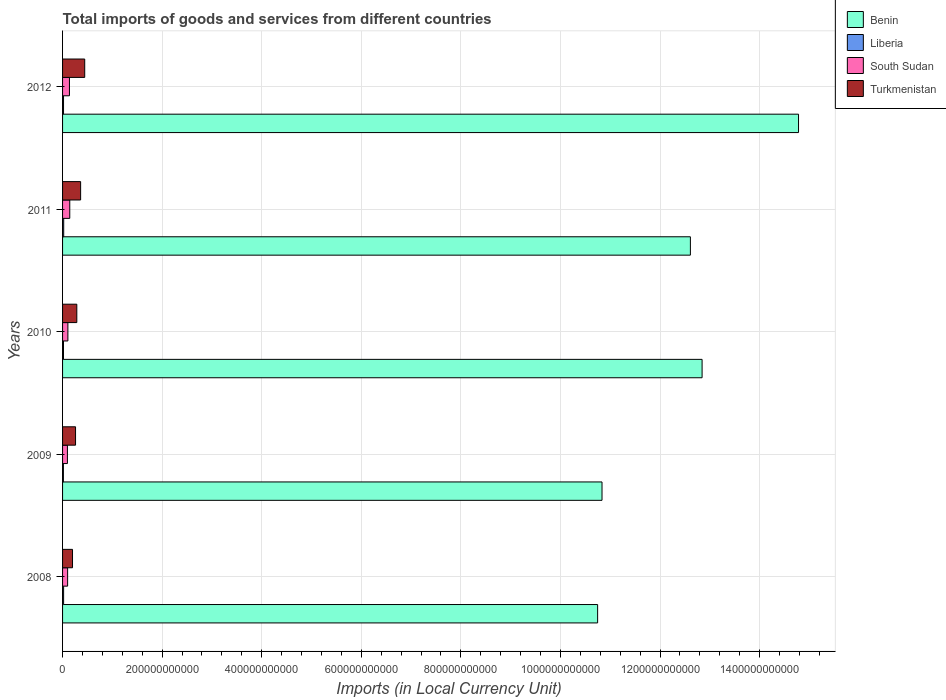How many different coloured bars are there?
Give a very brief answer. 4. Are the number of bars per tick equal to the number of legend labels?
Provide a short and direct response. Yes. Are the number of bars on each tick of the Y-axis equal?
Provide a succinct answer. Yes. How many bars are there on the 4th tick from the bottom?
Give a very brief answer. 4. What is the Amount of goods and services imports in Liberia in 2011?
Your answer should be very brief. 2.27e+09. Across all years, what is the maximum Amount of goods and services imports in South Sudan?
Ensure brevity in your answer.  1.45e+1. Across all years, what is the minimum Amount of goods and services imports in Turkmenistan?
Give a very brief answer. 2.00e+1. In which year was the Amount of goods and services imports in Benin maximum?
Your answer should be compact. 2012. What is the total Amount of goods and services imports in Turkmenistan in the graph?
Ensure brevity in your answer.  1.55e+11. What is the difference between the Amount of goods and services imports in Benin in 2009 and that in 2012?
Offer a terse response. -3.95e+11. What is the difference between the Amount of goods and services imports in Benin in 2010 and the Amount of goods and services imports in South Sudan in 2008?
Your response must be concise. 1.27e+12. What is the average Amount of goods and services imports in South Sudan per year?
Your answer should be compact. 1.18e+1. In the year 2008, what is the difference between the Amount of goods and services imports in Benin and Amount of goods and services imports in Liberia?
Give a very brief answer. 1.07e+12. What is the ratio of the Amount of goods and services imports in Liberia in 2008 to that in 2012?
Make the answer very short. 1.08. What is the difference between the highest and the second highest Amount of goods and services imports in South Sudan?
Offer a terse response. 6.23e+08. What is the difference between the highest and the lowest Amount of goods and services imports in Turkmenistan?
Offer a very short reply. 2.45e+1. In how many years, is the Amount of goods and services imports in Turkmenistan greater than the average Amount of goods and services imports in Turkmenistan taken over all years?
Your answer should be compact. 2. Is the sum of the Amount of goods and services imports in Benin in 2009 and 2010 greater than the maximum Amount of goods and services imports in Turkmenistan across all years?
Give a very brief answer. Yes. What does the 3rd bar from the top in 2010 represents?
Give a very brief answer. Liberia. What does the 1st bar from the bottom in 2009 represents?
Provide a succinct answer. Benin. Is it the case that in every year, the sum of the Amount of goods and services imports in South Sudan and Amount of goods and services imports in Liberia is greater than the Amount of goods and services imports in Turkmenistan?
Make the answer very short. No. Are all the bars in the graph horizontal?
Keep it short and to the point. Yes. What is the difference between two consecutive major ticks on the X-axis?
Provide a succinct answer. 2.00e+11. Where does the legend appear in the graph?
Keep it short and to the point. Top right. What is the title of the graph?
Your response must be concise. Total imports of goods and services from different countries. Does "Montenegro" appear as one of the legend labels in the graph?
Offer a very short reply. No. What is the label or title of the X-axis?
Your answer should be very brief. Imports (in Local Currency Unit). What is the label or title of the Y-axis?
Keep it short and to the point. Years. What is the Imports (in Local Currency Unit) in Benin in 2008?
Your response must be concise. 1.07e+12. What is the Imports (in Local Currency Unit) of Liberia in 2008?
Ensure brevity in your answer.  2.10e+09. What is the Imports (in Local Currency Unit) of South Sudan in 2008?
Provide a succinct answer. 1.02e+1. What is the Imports (in Local Currency Unit) of Turkmenistan in 2008?
Give a very brief answer. 2.00e+1. What is the Imports (in Local Currency Unit) of Benin in 2009?
Your answer should be very brief. 1.08e+12. What is the Imports (in Local Currency Unit) of Liberia in 2009?
Your response must be concise. 1.69e+09. What is the Imports (in Local Currency Unit) of South Sudan in 2009?
Provide a succinct answer. 9.75e+09. What is the Imports (in Local Currency Unit) of Turkmenistan in 2009?
Offer a terse response. 2.61e+1. What is the Imports (in Local Currency Unit) of Benin in 2010?
Offer a terse response. 1.28e+12. What is the Imports (in Local Currency Unit) in Liberia in 2010?
Your response must be concise. 1.89e+09. What is the Imports (in Local Currency Unit) of South Sudan in 2010?
Provide a short and direct response. 1.07e+1. What is the Imports (in Local Currency Unit) of Turkmenistan in 2010?
Provide a succinct answer. 2.86e+1. What is the Imports (in Local Currency Unit) of Benin in 2011?
Keep it short and to the point. 1.26e+12. What is the Imports (in Local Currency Unit) in Liberia in 2011?
Your answer should be very brief. 2.27e+09. What is the Imports (in Local Currency Unit) in South Sudan in 2011?
Offer a very short reply. 1.45e+1. What is the Imports (in Local Currency Unit) of Turkmenistan in 2011?
Your answer should be compact. 3.63e+1. What is the Imports (in Local Currency Unit) of Benin in 2012?
Provide a succinct answer. 1.48e+12. What is the Imports (in Local Currency Unit) in Liberia in 2012?
Keep it short and to the point. 1.95e+09. What is the Imports (in Local Currency Unit) in South Sudan in 2012?
Your answer should be very brief. 1.38e+1. What is the Imports (in Local Currency Unit) in Turkmenistan in 2012?
Ensure brevity in your answer.  4.45e+1. Across all years, what is the maximum Imports (in Local Currency Unit) in Benin?
Give a very brief answer. 1.48e+12. Across all years, what is the maximum Imports (in Local Currency Unit) in Liberia?
Offer a very short reply. 2.27e+09. Across all years, what is the maximum Imports (in Local Currency Unit) of South Sudan?
Ensure brevity in your answer.  1.45e+1. Across all years, what is the maximum Imports (in Local Currency Unit) in Turkmenistan?
Give a very brief answer. 4.45e+1. Across all years, what is the minimum Imports (in Local Currency Unit) of Benin?
Offer a terse response. 1.07e+12. Across all years, what is the minimum Imports (in Local Currency Unit) of Liberia?
Your answer should be compact. 1.69e+09. Across all years, what is the minimum Imports (in Local Currency Unit) in South Sudan?
Make the answer very short. 9.75e+09. Across all years, what is the minimum Imports (in Local Currency Unit) of Turkmenistan?
Provide a succinct answer. 2.00e+1. What is the total Imports (in Local Currency Unit) in Benin in the graph?
Give a very brief answer. 6.18e+12. What is the total Imports (in Local Currency Unit) in Liberia in the graph?
Give a very brief answer. 9.90e+09. What is the total Imports (in Local Currency Unit) in South Sudan in the graph?
Keep it short and to the point. 5.89e+1. What is the total Imports (in Local Currency Unit) of Turkmenistan in the graph?
Give a very brief answer. 1.55e+11. What is the difference between the Imports (in Local Currency Unit) in Benin in 2008 and that in 2009?
Offer a terse response. -8.80e+09. What is the difference between the Imports (in Local Currency Unit) of Liberia in 2008 and that in 2009?
Provide a short and direct response. 4.06e+08. What is the difference between the Imports (in Local Currency Unit) in South Sudan in 2008 and that in 2009?
Your answer should be very brief. 4.06e+08. What is the difference between the Imports (in Local Currency Unit) in Turkmenistan in 2008 and that in 2009?
Offer a terse response. -6.09e+09. What is the difference between the Imports (in Local Currency Unit) in Benin in 2008 and that in 2010?
Keep it short and to the point. -2.10e+11. What is the difference between the Imports (in Local Currency Unit) of Liberia in 2008 and that in 2010?
Offer a terse response. 2.07e+08. What is the difference between the Imports (in Local Currency Unit) of South Sudan in 2008 and that in 2010?
Provide a short and direct response. -5.38e+08. What is the difference between the Imports (in Local Currency Unit) of Turkmenistan in 2008 and that in 2010?
Give a very brief answer. -8.65e+09. What is the difference between the Imports (in Local Currency Unit) of Benin in 2008 and that in 2011?
Keep it short and to the point. -1.86e+11. What is the difference between the Imports (in Local Currency Unit) in Liberia in 2008 and that in 2011?
Your response must be concise. -1.76e+08. What is the difference between the Imports (in Local Currency Unit) in South Sudan in 2008 and that in 2011?
Provide a succinct answer. -4.31e+09. What is the difference between the Imports (in Local Currency Unit) in Turkmenistan in 2008 and that in 2011?
Offer a very short reply. -1.63e+1. What is the difference between the Imports (in Local Currency Unit) of Benin in 2008 and that in 2012?
Your response must be concise. -4.04e+11. What is the difference between the Imports (in Local Currency Unit) in Liberia in 2008 and that in 2012?
Provide a short and direct response. 1.50e+08. What is the difference between the Imports (in Local Currency Unit) in South Sudan in 2008 and that in 2012?
Your answer should be very brief. -3.68e+09. What is the difference between the Imports (in Local Currency Unit) in Turkmenistan in 2008 and that in 2012?
Offer a very short reply. -2.45e+1. What is the difference between the Imports (in Local Currency Unit) in Benin in 2009 and that in 2010?
Keep it short and to the point. -2.01e+11. What is the difference between the Imports (in Local Currency Unit) in Liberia in 2009 and that in 2010?
Ensure brevity in your answer.  -1.99e+08. What is the difference between the Imports (in Local Currency Unit) in South Sudan in 2009 and that in 2010?
Provide a short and direct response. -9.44e+08. What is the difference between the Imports (in Local Currency Unit) of Turkmenistan in 2009 and that in 2010?
Your answer should be compact. -2.56e+09. What is the difference between the Imports (in Local Currency Unit) in Benin in 2009 and that in 2011?
Provide a short and direct response. -1.78e+11. What is the difference between the Imports (in Local Currency Unit) of Liberia in 2009 and that in 2011?
Offer a terse response. -5.82e+08. What is the difference between the Imports (in Local Currency Unit) in South Sudan in 2009 and that in 2011?
Give a very brief answer. -4.71e+09. What is the difference between the Imports (in Local Currency Unit) of Turkmenistan in 2009 and that in 2011?
Offer a very short reply. -1.02e+1. What is the difference between the Imports (in Local Currency Unit) of Benin in 2009 and that in 2012?
Offer a terse response. -3.95e+11. What is the difference between the Imports (in Local Currency Unit) in Liberia in 2009 and that in 2012?
Offer a terse response. -2.56e+08. What is the difference between the Imports (in Local Currency Unit) in South Sudan in 2009 and that in 2012?
Provide a short and direct response. -4.09e+09. What is the difference between the Imports (in Local Currency Unit) in Turkmenistan in 2009 and that in 2012?
Keep it short and to the point. -1.84e+1. What is the difference between the Imports (in Local Currency Unit) in Benin in 2010 and that in 2011?
Your answer should be compact. 2.35e+1. What is the difference between the Imports (in Local Currency Unit) of Liberia in 2010 and that in 2011?
Offer a very short reply. -3.83e+08. What is the difference between the Imports (in Local Currency Unit) in South Sudan in 2010 and that in 2011?
Make the answer very short. -3.77e+09. What is the difference between the Imports (in Local Currency Unit) of Turkmenistan in 2010 and that in 2011?
Your response must be concise. -7.64e+09. What is the difference between the Imports (in Local Currency Unit) in Benin in 2010 and that in 2012?
Give a very brief answer. -1.94e+11. What is the difference between the Imports (in Local Currency Unit) of Liberia in 2010 and that in 2012?
Offer a terse response. -5.70e+07. What is the difference between the Imports (in Local Currency Unit) in South Sudan in 2010 and that in 2012?
Provide a succinct answer. -3.15e+09. What is the difference between the Imports (in Local Currency Unit) in Turkmenistan in 2010 and that in 2012?
Your answer should be compact. -1.59e+1. What is the difference between the Imports (in Local Currency Unit) in Benin in 2011 and that in 2012?
Provide a succinct answer. -2.17e+11. What is the difference between the Imports (in Local Currency Unit) in Liberia in 2011 and that in 2012?
Offer a terse response. 3.26e+08. What is the difference between the Imports (in Local Currency Unit) in South Sudan in 2011 and that in 2012?
Provide a short and direct response. 6.23e+08. What is the difference between the Imports (in Local Currency Unit) in Turkmenistan in 2011 and that in 2012?
Your answer should be compact. -8.22e+09. What is the difference between the Imports (in Local Currency Unit) of Benin in 2008 and the Imports (in Local Currency Unit) of Liberia in 2009?
Offer a terse response. 1.07e+12. What is the difference between the Imports (in Local Currency Unit) of Benin in 2008 and the Imports (in Local Currency Unit) of South Sudan in 2009?
Your answer should be very brief. 1.06e+12. What is the difference between the Imports (in Local Currency Unit) in Benin in 2008 and the Imports (in Local Currency Unit) in Turkmenistan in 2009?
Offer a very short reply. 1.05e+12. What is the difference between the Imports (in Local Currency Unit) of Liberia in 2008 and the Imports (in Local Currency Unit) of South Sudan in 2009?
Provide a short and direct response. -7.66e+09. What is the difference between the Imports (in Local Currency Unit) in Liberia in 2008 and the Imports (in Local Currency Unit) in Turkmenistan in 2009?
Give a very brief answer. -2.40e+1. What is the difference between the Imports (in Local Currency Unit) of South Sudan in 2008 and the Imports (in Local Currency Unit) of Turkmenistan in 2009?
Provide a short and direct response. -1.59e+1. What is the difference between the Imports (in Local Currency Unit) in Benin in 2008 and the Imports (in Local Currency Unit) in Liberia in 2010?
Offer a terse response. 1.07e+12. What is the difference between the Imports (in Local Currency Unit) in Benin in 2008 and the Imports (in Local Currency Unit) in South Sudan in 2010?
Keep it short and to the point. 1.06e+12. What is the difference between the Imports (in Local Currency Unit) in Benin in 2008 and the Imports (in Local Currency Unit) in Turkmenistan in 2010?
Offer a very short reply. 1.05e+12. What is the difference between the Imports (in Local Currency Unit) in Liberia in 2008 and the Imports (in Local Currency Unit) in South Sudan in 2010?
Your response must be concise. -8.60e+09. What is the difference between the Imports (in Local Currency Unit) of Liberia in 2008 and the Imports (in Local Currency Unit) of Turkmenistan in 2010?
Provide a short and direct response. -2.65e+1. What is the difference between the Imports (in Local Currency Unit) of South Sudan in 2008 and the Imports (in Local Currency Unit) of Turkmenistan in 2010?
Offer a very short reply. -1.85e+1. What is the difference between the Imports (in Local Currency Unit) of Benin in 2008 and the Imports (in Local Currency Unit) of Liberia in 2011?
Offer a terse response. 1.07e+12. What is the difference between the Imports (in Local Currency Unit) of Benin in 2008 and the Imports (in Local Currency Unit) of South Sudan in 2011?
Offer a very short reply. 1.06e+12. What is the difference between the Imports (in Local Currency Unit) in Benin in 2008 and the Imports (in Local Currency Unit) in Turkmenistan in 2011?
Your answer should be very brief. 1.04e+12. What is the difference between the Imports (in Local Currency Unit) of Liberia in 2008 and the Imports (in Local Currency Unit) of South Sudan in 2011?
Your response must be concise. -1.24e+1. What is the difference between the Imports (in Local Currency Unit) in Liberia in 2008 and the Imports (in Local Currency Unit) in Turkmenistan in 2011?
Ensure brevity in your answer.  -3.42e+1. What is the difference between the Imports (in Local Currency Unit) in South Sudan in 2008 and the Imports (in Local Currency Unit) in Turkmenistan in 2011?
Provide a short and direct response. -2.61e+1. What is the difference between the Imports (in Local Currency Unit) of Benin in 2008 and the Imports (in Local Currency Unit) of Liberia in 2012?
Your answer should be very brief. 1.07e+12. What is the difference between the Imports (in Local Currency Unit) of Benin in 2008 and the Imports (in Local Currency Unit) of South Sudan in 2012?
Give a very brief answer. 1.06e+12. What is the difference between the Imports (in Local Currency Unit) in Benin in 2008 and the Imports (in Local Currency Unit) in Turkmenistan in 2012?
Ensure brevity in your answer.  1.03e+12. What is the difference between the Imports (in Local Currency Unit) in Liberia in 2008 and the Imports (in Local Currency Unit) in South Sudan in 2012?
Offer a terse response. -1.17e+1. What is the difference between the Imports (in Local Currency Unit) of Liberia in 2008 and the Imports (in Local Currency Unit) of Turkmenistan in 2012?
Give a very brief answer. -4.24e+1. What is the difference between the Imports (in Local Currency Unit) in South Sudan in 2008 and the Imports (in Local Currency Unit) in Turkmenistan in 2012?
Your answer should be very brief. -3.43e+1. What is the difference between the Imports (in Local Currency Unit) in Benin in 2009 and the Imports (in Local Currency Unit) in Liberia in 2010?
Ensure brevity in your answer.  1.08e+12. What is the difference between the Imports (in Local Currency Unit) of Benin in 2009 and the Imports (in Local Currency Unit) of South Sudan in 2010?
Give a very brief answer. 1.07e+12. What is the difference between the Imports (in Local Currency Unit) in Benin in 2009 and the Imports (in Local Currency Unit) in Turkmenistan in 2010?
Give a very brief answer. 1.05e+12. What is the difference between the Imports (in Local Currency Unit) in Liberia in 2009 and the Imports (in Local Currency Unit) in South Sudan in 2010?
Provide a short and direct response. -9.00e+09. What is the difference between the Imports (in Local Currency Unit) in Liberia in 2009 and the Imports (in Local Currency Unit) in Turkmenistan in 2010?
Your answer should be compact. -2.69e+1. What is the difference between the Imports (in Local Currency Unit) of South Sudan in 2009 and the Imports (in Local Currency Unit) of Turkmenistan in 2010?
Your response must be concise. -1.89e+1. What is the difference between the Imports (in Local Currency Unit) in Benin in 2009 and the Imports (in Local Currency Unit) in Liberia in 2011?
Your response must be concise. 1.08e+12. What is the difference between the Imports (in Local Currency Unit) in Benin in 2009 and the Imports (in Local Currency Unit) in South Sudan in 2011?
Ensure brevity in your answer.  1.07e+12. What is the difference between the Imports (in Local Currency Unit) of Benin in 2009 and the Imports (in Local Currency Unit) of Turkmenistan in 2011?
Your answer should be very brief. 1.05e+12. What is the difference between the Imports (in Local Currency Unit) in Liberia in 2009 and the Imports (in Local Currency Unit) in South Sudan in 2011?
Ensure brevity in your answer.  -1.28e+1. What is the difference between the Imports (in Local Currency Unit) of Liberia in 2009 and the Imports (in Local Currency Unit) of Turkmenistan in 2011?
Keep it short and to the point. -3.46e+1. What is the difference between the Imports (in Local Currency Unit) of South Sudan in 2009 and the Imports (in Local Currency Unit) of Turkmenistan in 2011?
Offer a terse response. -2.65e+1. What is the difference between the Imports (in Local Currency Unit) of Benin in 2009 and the Imports (in Local Currency Unit) of Liberia in 2012?
Keep it short and to the point. 1.08e+12. What is the difference between the Imports (in Local Currency Unit) in Benin in 2009 and the Imports (in Local Currency Unit) in South Sudan in 2012?
Your answer should be compact. 1.07e+12. What is the difference between the Imports (in Local Currency Unit) in Benin in 2009 and the Imports (in Local Currency Unit) in Turkmenistan in 2012?
Ensure brevity in your answer.  1.04e+12. What is the difference between the Imports (in Local Currency Unit) of Liberia in 2009 and the Imports (in Local Currency Unit) of South Sudan in 2012?
Your answer should be compact. -1.22e+1. What is the difference between the Imports (in Local Currency Unit) of Liberia in 2009 and the Imports (in Local Currency Unit) of Turkmenistan in 2012?
Keep it short and to the point. -4.28e+1. What is the difference between the Imports (in Local Currency Unit) of South Sudan in 2009 and the Imports (in Local Currency Unit) of Turkmenistan in 2012?
Make the answer very short. -3.47e+1. What is the difference between the Imports (in Local Currency Unit) of Benin in 2010 and the Imports (in Local Currency Unit) of Liberia in 2011?
Provide a short and direct response. 1.28e+12. What is the difference between the Imports (in Local Currency Unit) in Benin in 2010 and the Imports (in Local Currency Unit) in South Sudan in 2011?
Offer a very short reply. 1.27e+12. What is the difference between the Imports (in Local Currency Unit) in Benin in 2010 and the Imports (in Local Currency Unit) in Turkmenistan in 2011?
Offer a very short reply. 1.25e+12. What is the difference between the Imports (in Local Currency Unit) of Liberia in 2010 and the Imports (in Local Currency Unit) of South Sudan in 2011?
Keep it short and to the point. -1.26e+1. What is the difference between the Imports (in Local Currency Unit) of Liberia in 2010 and the Imports (in Local Currency Unit) of Turkmenistan in 2011?
Provide a short and direct response. -3.44e+1. What is the difference between the Imports (in Local Currency Unit) of South Sudan in 2010 and the Imports (in Local Currency Unit) of Turkmenistan in 2011?
Keep it short and to the point. -2.56e+1. What is the difference between the Imports (in Local Currency Unit) of Benin in 2010 and the Imports (in Local Currency Unit) of Liberia in 2012?
Give a very brief answer. 1.28e+12. What is the difference between the Imports (in Local Currency Unit) in Benin in 2010 and the Imports (in Local Currency Unit) in South Sudan in 2012?
Offer a very short reply. 1.27e+12. What is the difference between the Imports (in Local Currency Unit) in Benin in 2010 and the Imports (in Local Currency Unit) in Turkmenistan in 2012?
Offer a terse response. 1.24e+12. What is the difference between the Imports (in Local Currency Unit) in Liberia in 2010 and the Imports (in Local Currency Unit) in South Sudan in 2012?
Offer a terse response. -1.20e+1. What is the difference between the Imports (in Local Currency Unit) of Liberia in 2010 and the Imports (in Local Currency Unit) of Turkmenistan in 2012?
Provide a succinct answer. -4.26e+1. What is the difference between the Imports (in Local Currency Unit) of South Sudan in 2010 and the Imports (in Local Currency Unit) of Turkmenistan in 2012?
Your answer should be compact. -3.38e+1. What is the difference between the Imports (in Local Currency Unit) in Benin in 2011 and the Imports (in Local Currency Unit) in Liberia in 2012?
Make the answer very short. 1.26e+12. What is the difference between the Imports (in Local Currency Unit) of Benin in 2011 and the Imports (in Local Currency Unit) of South Sudan in 2012?
Offer a terse response. 1.25e+12. What is the difference between the Imports (in Local Currency Unit) in Benin in 2011 and the Imports (in Local Currency Unit) in Turkmenistan in 2012?
Give a very brief answer. 1.22e+12. What is the difference between the Imports (in Local Currency Unit) of Liberia in 2011 and the Imports (in Local Currency Unit) of South Sudan in 2012?
Your answer should be very brief. -1.16e+1. What is the difference between the Imports (in Local Currency Unit) of Liberia in 2011 and the Imports (in Local Currency Unit) of Turkmenistan in 2012?
Ensure brevity in your answer.  -4.22e+1. What is the difference between the Imports (in Local Currency Unit) in South Sudan in 2011 and the Imports (in Local Currency Unit) in Turkmenistan in 2012?
Provide a succinct answer. -3.00e+1. What is the average Imports (in Local Currency Unit) in Benin per year?
Provide a short and direct response. 1.24e+12. What is the average Imports (in Local Currency Unit) of Liberia per year?
Your answer should be very brief. 1.98e+09. What is the average Imports (in Local Currency Unit) in South Sudan per year?
Offer a very short reply. 1.18e+1. What is the average Imports (in Local Currency Unit) in Turkmenistan per year?
Give a very brief answer. 3.11e+1. In the year 2008, what is the difference between the Imports (in Local Currency Unit) in Benin and Imports (in Local Currency Unit) in Liberia?
Offer a terse response. 1.07e+12. In the year 2008, what is the difference between the Imports (in Local Currency Unit) in Benin and Imports (in Local Currency Unit) in South Sudan?
Your answer should be compact. 1.06e+12. In the year 2008, what is the difference between the Imports (in Local Currency Unit) of Benin and Imports (in Local Currency Unit) of Turkmenistan?
Your response must be concise. 1.05e+12. In the year 2008, what is the difference between the Imports (in Local Currency Unit) of Liberia and Imports (in Local Currency Unit) of South Sudan?
Your response must be concise. -8.06e+09. In the year 2008, what is the difference between the Imports (in Local Currency Unit) of Liberia and Imports (in Local Currency Unit) of Turkmenistan?
Your answer should be compact. -1.79e+1. In the year 2008, what is the difference between the Imports (in Local Currency Unit) in South Sudan and Imports (in Local Currency Unit) in Turkmenistan?
Your response must be concise. -9.81e+09. In the year 2009, what is the difference between the Imports (in Local Currency Unit) of Benin and Imports (in Local Currency Unit) of Liberia?
Offer a terse response. 1.08e+12. In the year 2009, what is the difference between the Imports (in Local Currency Unit) of Benin and Imports (in Local Currency Unit) of South Sudan?
Keep it short and to the point. 1.07e+12. In the year 2009, what is the difference between the Imports (in Local Currency Unit) of Benin and Imports (in Local Currency Unit) of Turkmenistan?
Your response must be concise. 1.06e+12. In the year 2009, what is the difference between the Imports (in Local Currency Unit) in Liberia and Imports (in Local Currency Unit) in South Sudan?
Ensure brevity in your answer.  -8.06e+09. In the year 2009, what is the difference between the Imports (in Local Currency Unit) of Liberia and Imports (in Local Currency Unit) of Turkmenistan?
Provide a short and direct response. -2.44e+1. In the year 2009, what is the difference between the Imports (in Local Currency Unit) of South Sudan and Imports (in Local Currency Unit) of Turkmenistan?
Your answer should be very brief. -1.63e+1. In the year 2010, what is the difference between the Imports (in Local Currency Unit) of Benin and Imports (in Local Currency Unit) of Liberia?
Offer a very short reply. 1.28e+12. In the year 2010, what is the difference between the Imports (in Local Currency Unit) in Benin and Imports (in Local Currency Unit) in South Sudan?
Keep it short and to the point. 1.27e+12. In the year 2010, what is the difference between the Imports (in Local Currency Unit) in Benin and Imports (in Local Currency Unit) in Turkmenistan?
Your answer should be compact. 1.26e+12. In the year 2010, what is the difference between the Imports (in Local Currency Unit) in Liberia and Imports (in Local Currency Unit) in South Sudan?
Ensure brevity in your answer.  -8.81e+09. In the year 2010, what is the difference between the Imports (in Local Currency Unit) in Liberia and Imports (in Local Currency Unit) in Turkmenistan?
Your response must be concise. -2.67e+1. In the year 2010, what is the difference between the Imports (in Local Currency Unit) in South Sudan and Imports (in Local Currency Unit) in Turkmenistan?
Offer a very short reply. -1.79e+1. In the year 2011, what is the difference between the Imports (in Local Currency Unit) in Benin and Imports (in Local Currency Unit) in Liberia?
Your answer should be very brief. 1.26e+12. In the year 2011, what is the difference between the Imports (in Local Currency Unit) of Benin and Imports (in Local Currency Unit) of South Sudan?
Provide a short and direct response. 1.25e+12. In the year 2011, what is the difference between the Imports (in Local Currency Unit) of Benin and Imports (in Local Currency Unit) of Turkmenistan?
Give a very brief answer. 1.22e+12. In the year 2011, what is the difference between the Imports (in Local Currency Unit) of Liberia and Imports (in Local Currency Unit) of South Sudan?
Provide a short and direct response. -1.22e+1. In the year 2011, what is the difference between the Imports (in Local Currency Unit) in Liberia and Imports (in Local Currency Unit) in Turkmenistan?
Provide a short and direct response. -3.40e+1. In the year 2011, what is the difference between the Imports (in Local Currency Unit) in South Sudan and Imports (in Local Currency Unit) in Turkmenistan?
Offer a terse response. -2.18e+1. In the year 2012, what is the difference between the Imports (in Local Currency Unit) in Benin and Imports (in Local Currency Unit) in Liberia?
Make the answer very short. 1.48e+12. In the year 2012, what is the difference between the Imports (in Local Currency Unit) of Benin and Imports (in Local Currency Unit) of South Sudan?
Provide a succinct answer. 1.46e+12. In the year 2012, what is the difference between the Imports (in Local Currency Unit) in Benin and Imports (in Local Currency Unit) in Turkmenistan?
Offer a very short reply. 1.43e+12. In the year 2012, what is the difference between the Imports (in Local Currency Unit) in Liberia and Imports (in Local Currency Unit) in South Sudan?
Your answer should be compact. -1.19e+1. In the year 2012, what is the difference between the Imports (in Local Currency Unit) in Liberia and Imports (in Local Currency Unit) in Turkmenistan?
Your answer should be compact. -4.25e+1. In the year 2012, what is the difference between the Imports (in Local Currency Unit) in South Sudan and Imports (in Local Currency Unit) in Turkmenistan?
Keep it short and to the point. -3.06e+1. What is the ratio of the Imports (in Local Currency Unit) in Liberia in 2008 to that in 2009?
Your answer should be compact. 1.24. What is the ratio of the Imports (in Local Currency Unit) in South Sudan in 2008 to that in 2009?
Your answer should be compact. 1.04. What is the ratio of the Imports (in Local Currency Unit) of Turkmenistan in 2008 to that in 2009?
Offer a very short reply. 0.77. What is the ratio of the Imports (in Local Currency Unit) in Benin in 2008 to that in 2010?
Keep it short and to the point. 0.84. What is the ratio of the Imports (in Local Currency Unit) of Liberia in 2008 to that in 2010?
Provide a short and direct response. 1.11. What is the ratio of the Imports (in Local Currency Unit) in South Sudan in 2008 to that in 2010?
Provide a succinct answer. 0.95. What is the ratio of the Imports (in Local Currency Unit) in Turkmenistan in 2008 to that in 2010?
Ensure brevity in your answer.  0.7. What is the ratio of the Imports (in Local Currency Unit) in Benin in 2008 to that in 2011?
Make the answer very short. 0.85. What is the ratio of the Imports (in Local Currency Unit) of Liberia in 2008 to that in 2011?
Ensure brevity in your answer.  0.92. What is the ratio of the Imports (in Local Currency Unit) in South Sudan in 2008 to that in 2011?
Keep it short and to the point. 0.7. What is the ratio of the Imports (in Local Currency Unit) of Turkmenistan in 2008 to that in 2011?
Provide a succinct answer. 0.55. What is the ratio of the Imports (in Local Currency Unit) of Benin in 2008 to that in 2012?
Give a very brief answer. 0.73. What is the ratio of the Imports (in Local Currency Unit) in Liberia in 2008 to that in 2012?
Offer a terse response. 1.08. What is the ratio of the Imports (in Local Currency Unit) of South Sudan in 2008 to that in 2012?
Offer a very short reply. 0.73. What is the ratio of the Imports (in Local Currency Unit) of Turkmenistan in 2008 to that in 2012?
Your response must be concise. 0.45. What is the ratio of the Imports (in Local Currency Unit) in Benin in 2009 to that in 2010?
Ensure brevity in your answer.  0.84. What is the ratio of the Imports (in Local Currency Unit) in Liberia in 2009 to that in 2010?
Offer a very short reply. 0.89. What is the ratio of the Imports (in Local Currency Unit) in South Sudan in 2009 to that in 2010?
Your answer should be very brief. 0.91. What is the ratio of the Imports (in Local Currency Unit) in Turkmenistan in 2009 to that in 2010?
Your answer should be compact. 0.91. What is the ratio of the Imports (in Local Currency Unit) in Benin in 2009 to that in 2011?
Your answer should be very brief. 0.86. What is the ratio of the Imports (in Local Currency Unit) in Liberia in 2009 to that in 2011?
Keep it short and to the point. 0.74. What is the ratio of the Imports (in Local Currency Unit) in South Sudan in 2009 to that in 2011?
Offer a terse response. 0.67. What is the ratio of the Imports (in Local Currency Unit) in Turkmenistan in 2009 to that in 2011?
Give a very brief answer. 0.72. What is the ratio of the Imports (in Local Currency Unit) in Benin in 2009 to that in 2012?
Provide a succinct answer. 0.73. What is the ratio of the Imports (in Local Currency Unit) in Liberia in 2009 to that in 2012?
Provide a succinct answer. 0.87. What is the ratio of the Imports (in Local Currency Unit) of South Sudan in 2009 to that in 2012?
Your answer should be very brief. 0.7. What is the ratio of the Imports (in Local Currency Unit) of Turkmenistan in 2009 to that in 2012?
Provide a short and direct response. 0.59. What is the ratio of the Imports (in Local Currency Unit) of Benin in 2010 to that in 2011?
Offer a very short reply. 1.02. What is the ratio of the Imports (in Local Currency Unit) of Liberia in 2010 to that in 2011?
Provide a succinct answer. 0.83. What is the ratio of the Imports (in Local Currency Unit) of South Sudan in 2010 to that in 2011?
Your answer should be very brief. 0.74. What is the ratio of the Imports (in Local Currency Unit) in Turkmenistan in 2010 to that in 2011?
Offer a terse response. 0.79. What is the ratio of the Imports (in Local Currency Unit) in Benin in 2010 to that in 2012?
Your response must be concise. 0.87. What is the ratio of the Imports (in Local Currency Unit) in Liberia in 2010 to that in 2012?
Offer a terse response. 0.97. What is the ratio of the Imports (in Local Currency Unit) in South Sudan in 2010 to that in 2012?
Your response must be concise. 0.77. What is the ratio of the Imports (in Local Currency Unit) in Turkmenistan in 2010 to that in 2012?
Offer a very short reply. 0.64. What is the ratio of the Imports (in Local Currency Unit) in Benin in 2011 to that in 2012?
Your answer should be very brief. 0.85. What is the ratio of the Imports (in Local Currency Unit) in Liberia in 2011 to that in 2012?
Give a very brief answer. 1.17. What is the ratio of the Imports (in Local Currency Unit) in South Sudan in 2011 to that in 2012?
Offer a very short reply. 1.04. What is the ratio of the Imports (in Local Currency Unit) of Turkmenistan in 2011 to that in 2012?
Offer a very short reply. 0.82. What is the difference between the highest and the second highest Imports (in Local Currency Unit) of Benin?
Your answer should be very brief. 1.94e+11. What is the difference between the highest and the second highest Imports (in Local Currency Unit) in Liberia?
Provide a short and direct response. 1.76e+08. What is the difference between the highest and the second highest Imports (in Local Currency Unit) of South Sudan?
Your answer should be compact. 6.23e+08. What is the difference between the highest and the second highest Imports (in Local Currency Unit) in Turkmenistan?
Provide a short and direct response. 8.22e+09. What is the difference between the highest and the lowest Imports (in Local Currency Unit) of Benin?
Your response must be concise. 4.04e+11. What is the difference between the highest and the lowest Imports (in Local Currency Unit) in Liberia?
Your answer should be compact. 5.82e+08. What is the difference between the highest and the lowest Imports (in Local Currency Unit) in South Sudan?
Your response must be concise. 4.71e+09. What is the difference between the highest and the lowest Imports (in Local Currency Unit) in Turkmenistan?
Your answer should be very brief. 2.45e+1. 